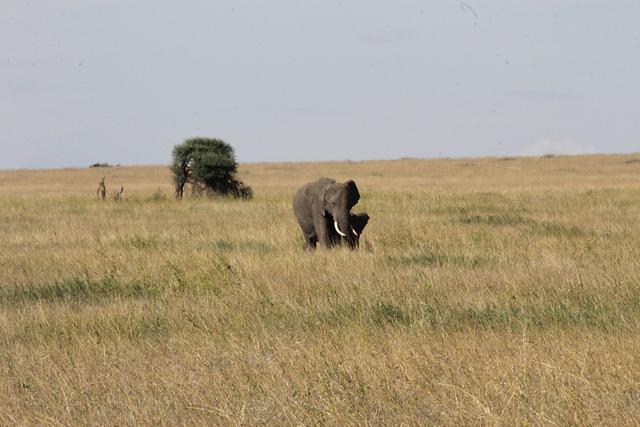How many animals?
Give a very brief answer. 1. 